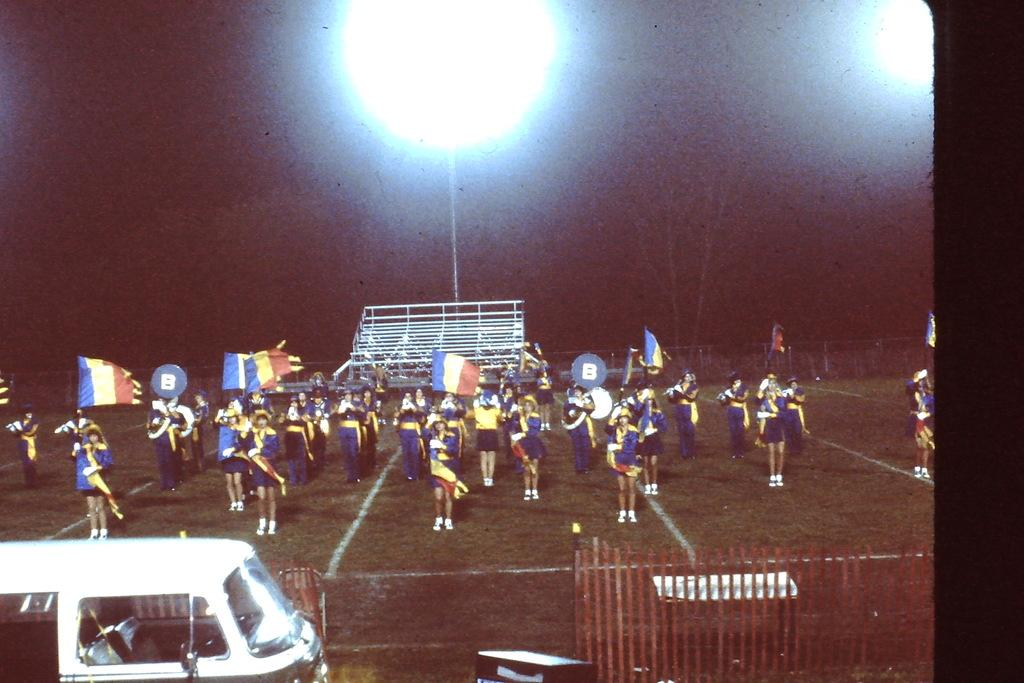What is the main subject of the image? The main subject of the image is a group of persons on the ground. What else can be seen in the image besides the group of persons? There are flags and a fence in the image. Is there any transportation visible in the image? Yes, there is a vehicle in the image. What type of powder is being used by the dad in the image? There is no dad present in the image, and therefore no one is using any powder. 